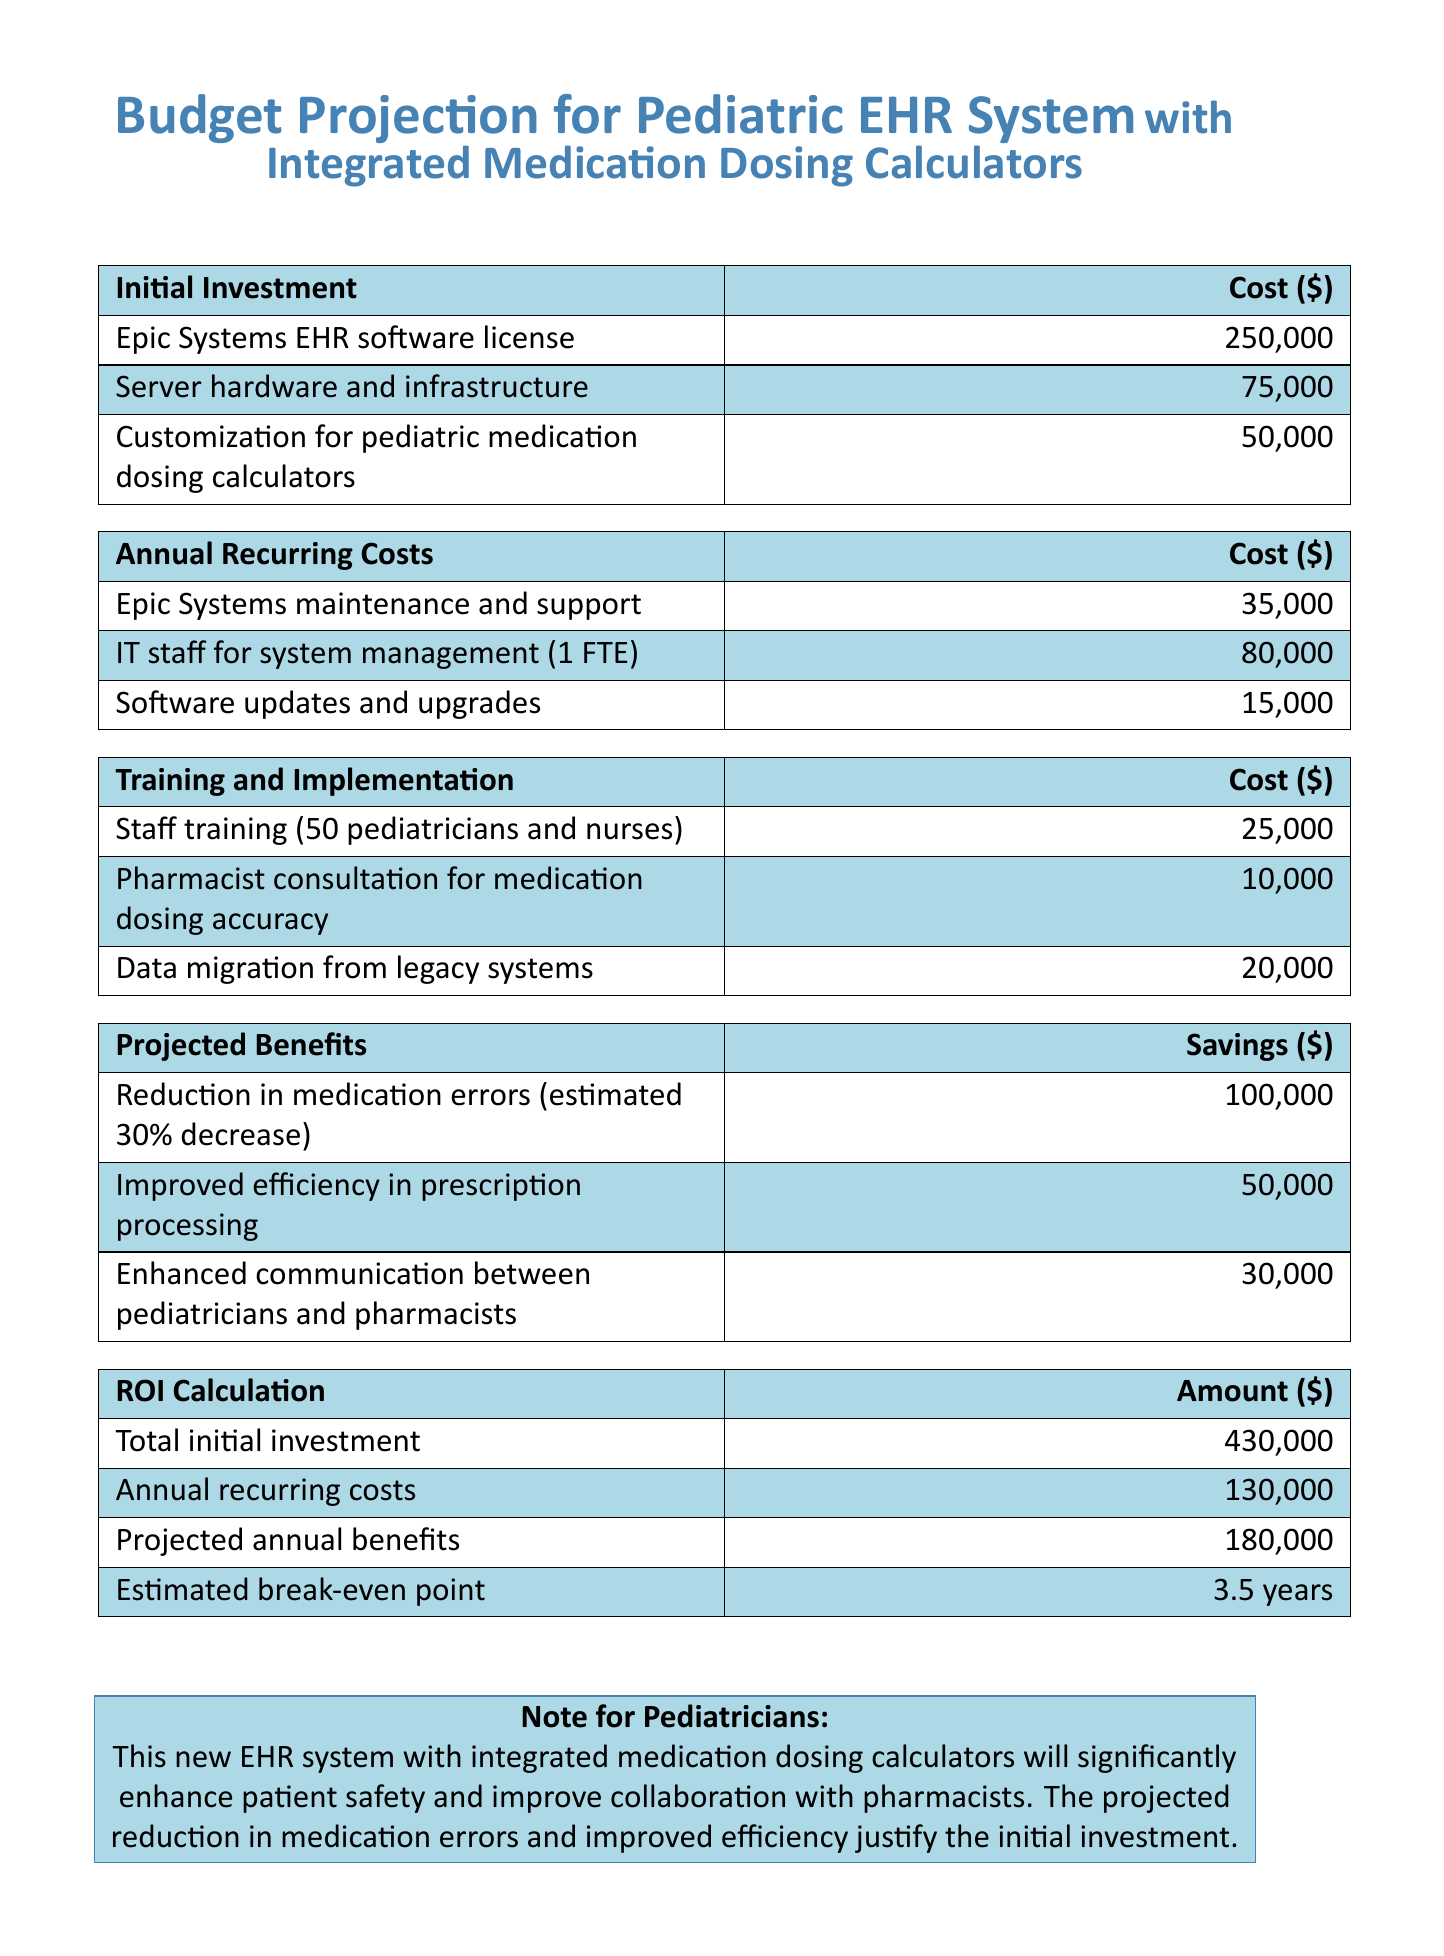What is the initial investment total? The initial investment total is calculated by summing all initial cost items listed in the document.
Answer: $430,000 How much is allocated for staff training? The document specifies the cost for staff training for pediatricians and nurses.
Answer: $25,000 What are the projected annual benefits? The projected annual benefits include savings from various sources, which totals to $180,000.
Answer: $180,000 What is the estimated break-even point? The estimated break-even point is clearly stated in the ROI Calculation section.
Answer: 3.5 years How much does the maintenance and support cost annually? The annual recurring cost for maintenance and support is indicated in the document.
Answer: $35,000 What is the savings from reduced medication errors? The document estimates the savings from reducing medication errors by a certain percentage.
Answer: $100,000 What is the cost for pharmacist consultation? The document lists the cost associated with pharmacist consultation for accuracy in medication dosing.
Answer: $10,000 How many pediatricians and nurses will be trained? The total number of pediatricians and nurses mentioned for training purposes is provided in the document.
Answer: 50 What hardware is included in the initial investment? The specific item listed under initial investment related to hardware is mentioned in the document.
Answer: Server hardware and infrastructure What is the purpose of the integrated medication dosing calculators? The document states the function of the integrated medication dosing calculators regarding patient safety and efficiency.
Answer: Enhance patient safety and improve collaboration with pharmacists 